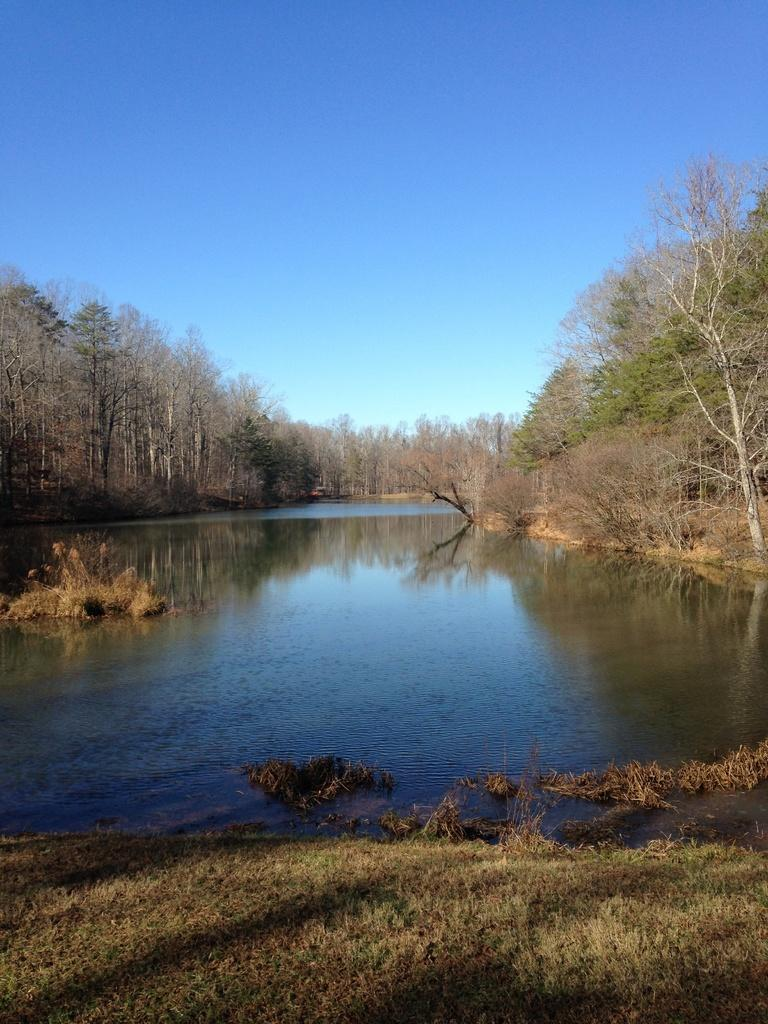What type of vegetation is visible at the front of the image? There is grass in front of the image. What can be seen in the middle of the image? There is water in the middle of the image. What other natural elements are present in the image? There are trees in the image. What is visible in the background of the image? The sky is clear and visible in the background of the image. How does the animal balance itself on the water in the image? There is no animal present in the image, so the question of balance is not applicable. 